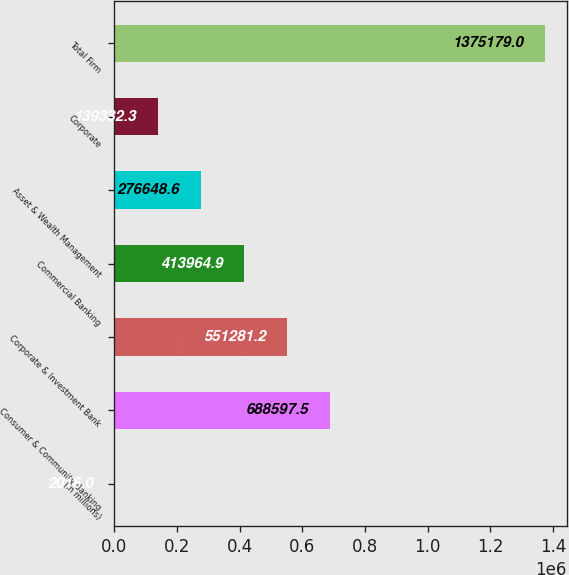<chart> <loc_0><loc_0><loc_500><loc_500><bar_chart><fcel>(in millions)<fcel>Consumer & Community Banking<fcel>Corporate & Investment Bank<fcel>Commercial Banking<fcel>Asset & Wealth Management<fcel>Corporate<fcel>Total Firm<nl><fcel>2016<fcel>688598<fcel>551281<fcel>413965<fcel>276649<fcel>139332<fcel>1.37518e+06<nl></chart> 